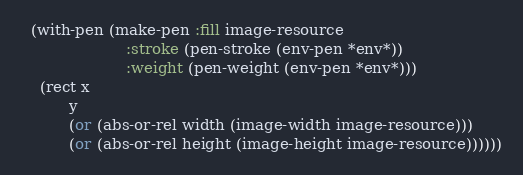Convert code to text. <code><loc_0><loc_0><loc_500><loc_500><_Lisp_>  (with-pen (make-pen :fill image-resource
                      :stroke (pen-stroke (env-pen *env*))
                      :weight (pen-weight (env-pen *env*)))
    (rect x
          y
          (or (abs-or-rel width (image-width image-resource)))
          (or (abs-or-rel height (image-height image-resource))))))
</code> 